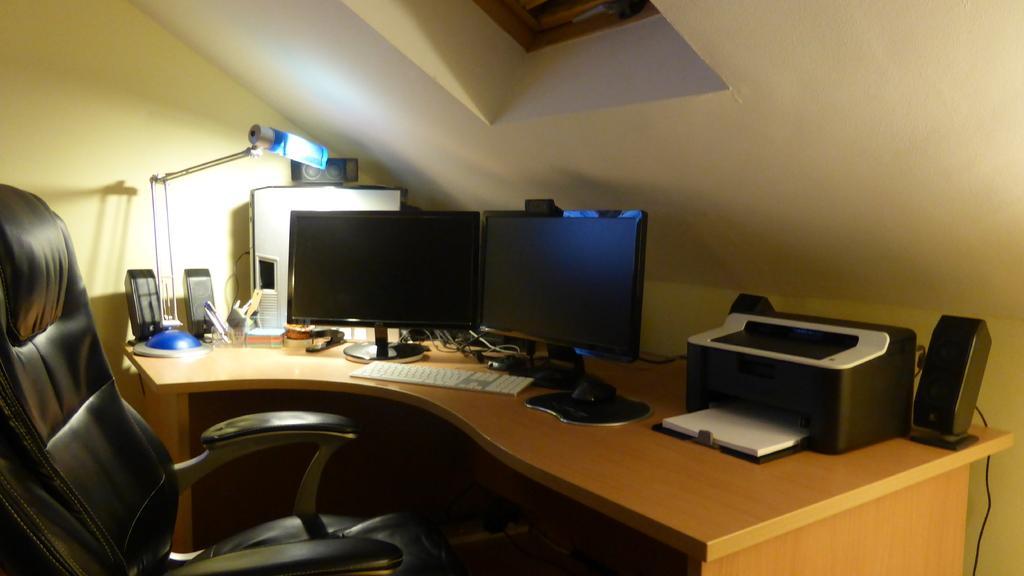Could you give a brief overview of what you see in this image? In this room we can able to see chair and table. On this table there are speakers, CPU, lamp, monitors, printer, mouse and keyboard. This chair is in black color. 